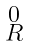Convert formula to latex. <formula><loc_0><loc_0><loc_500><loc_500>\begin{smallmatrix} 0 \\ R \end{smallmatrix}</formula> 